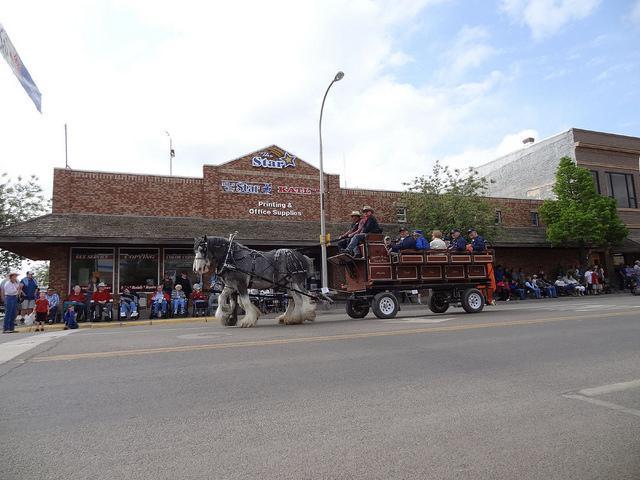How many horses are there?
Give a very brief answer. 2. 